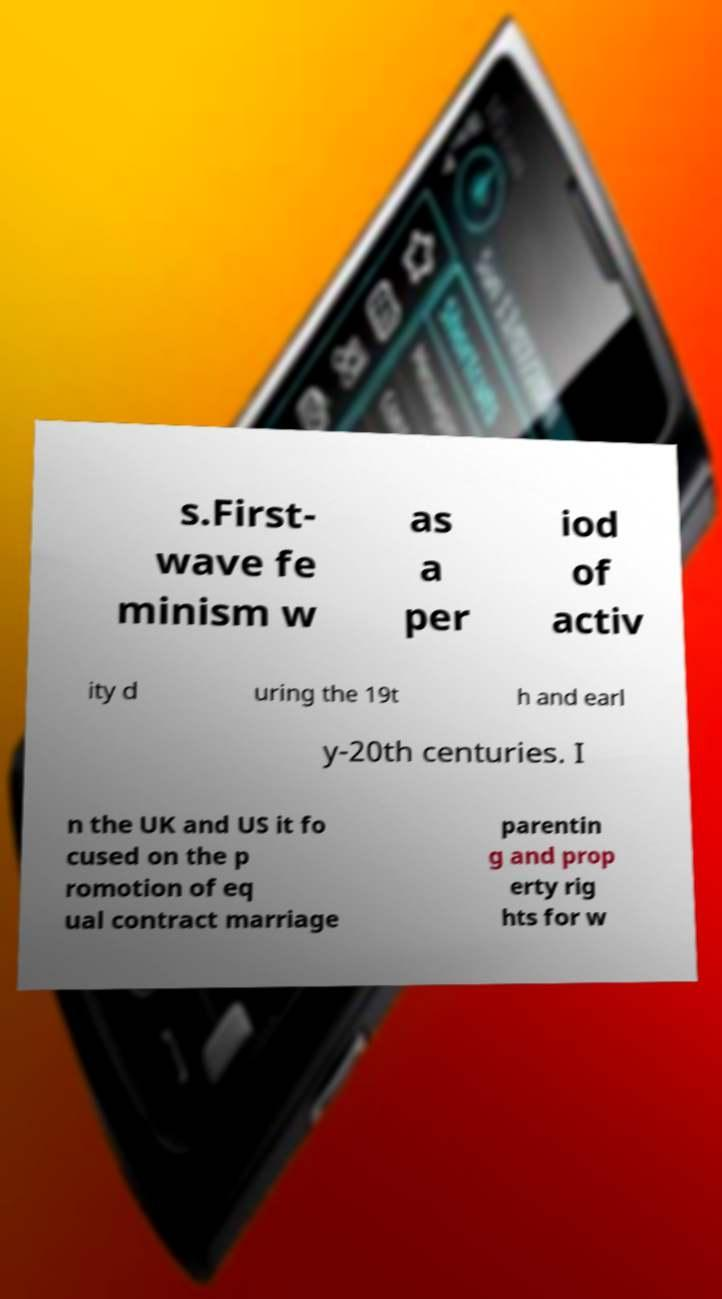Please identify and transcribe the text found in this image. s.First- wave fe minism w as a per iod of activ ity d uring the 19t h and earl y-20th centuries. I n the UK and US it fo cused on the p romotion of eq ual contract marriage parentin g and prop erty rig hts for w 